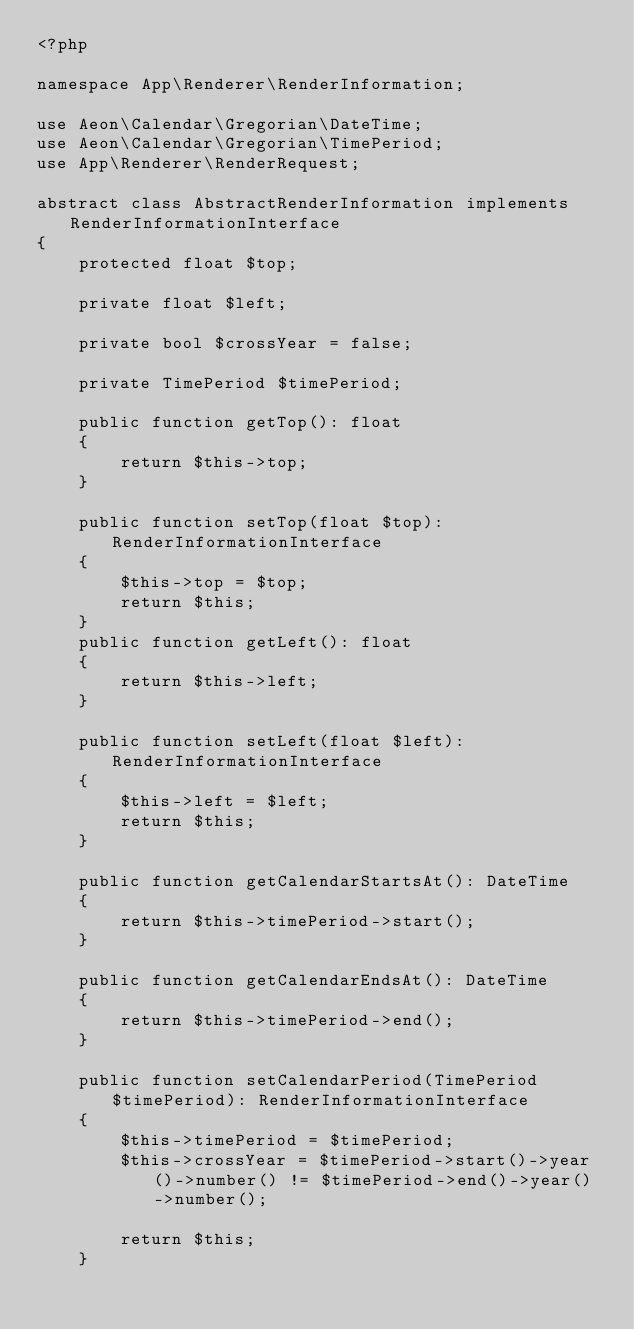Convert code to text. <code><loc_0><loc_0><loc_500><loc_500><_PHP_><?php

namespace App\Renderer\RenderInformation;

use Aeon\Calendar\Gregorian\DateTime;
use Aeon\Calendar\Gregorian\TimePeriod;
use App\Renderer\RenderRequest;

abstract class AbstractRenderInformation implements RenderInformationInterface
{
    protected float $top;

    private float $left;

    private bool $crossYear = false;

    private TimePeriod $timePeriod;

    public function getTop(): float
    {
        return $this->top;
    }

    public function setTop(float $top): RenderInformationInterface
    {
        $this->top = $top;
        return $this;
    }
    public function getLeft(): float
    {
        return $this->left;
    }

    public function setLeft(float $left): RenderInformationInterface
    {
        $this->left = $left;
        return $this;
    }

    public function getCalendarStartsAt(): DateTime
    {
        return $this->timePeriod->start();
    }

    public function getCalendarEndsAt(): DateTime
    {
        return $this->timePeriod->end();
    }

    public function setCalendarPeriod(TimePeriod $timePeriod): RenderInformationInterface
    {
        $this->timePeriod = $timePeriod;
        $this->crossYear = $timePeriod->start()->year()->number() != $timePeriod->end()->year()->number();

        return $this;
    }
</code> 